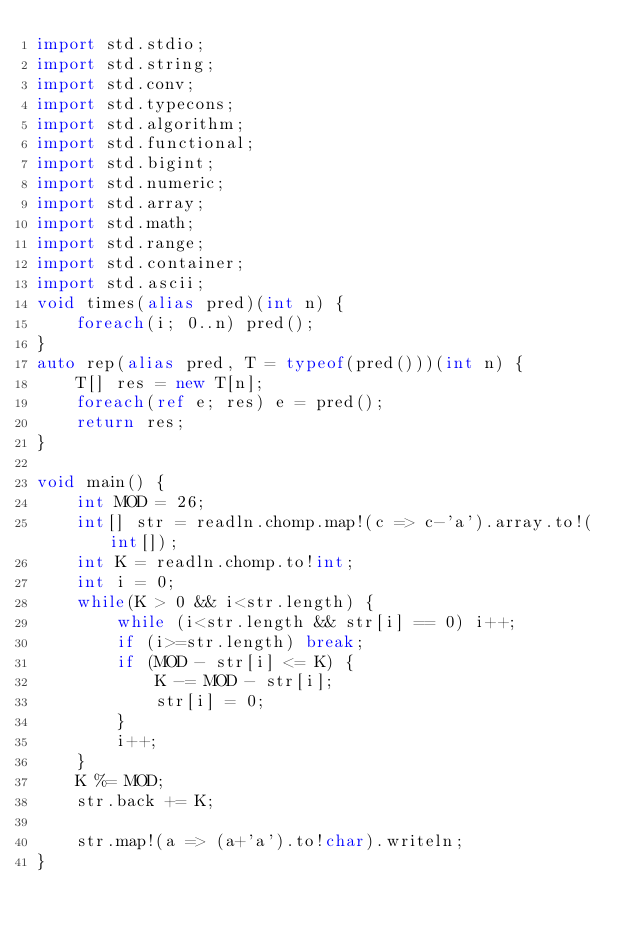Convert code to text. <code><loc_0><loc_0><loc_500><loc_500><_D_>import std.stdio;
import std.string;
import std.conv;
import std.typecons;
import std.algorithm;
import std.functional;
import std.bigint;
import std.numeric;
import std.array;
import std.math;
import std.range;
import std.container;
import std.ascii;
void times(alias pred)(int n) {
    foreach(i; 0..n) pred();
}
auto rep(alias pred, T = typeof(pred()))(int n) {
    T[] res = new T[n];
    foreach(ref e; res) e = pred();
    return res;
}

void main() {
    int MOD = 26;
    int[] str = readln.chomp.map!(c => c-'a').array.to!(int[]);
    int K = readln.chomp.to!int;
    int i = 0;
    while(K > 0 && i<str.length) {
        while (i<str.length && str[i] == 0) i++;
        if (i>=str.length) break;
        if (MOD - str[i] <= K) {
            K -= MOD - str[i];
            str[i] = 0;
        }
        i++;
    }
    K %= MOD;
    str.back += K;

    str.map!(a => (a+'a').to!char).writeln;
}
</code> 